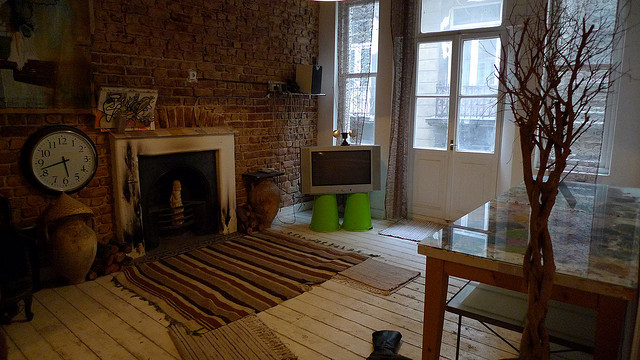What can you tell me about the light in the room? The room is bathed in a soft, natural light coming from the large window, which gives the space a serene and inviting ambiance. This light accentuates the room's textures and colors, such as the warm reds and browns of the brick wall and the contrasting white window frame. 